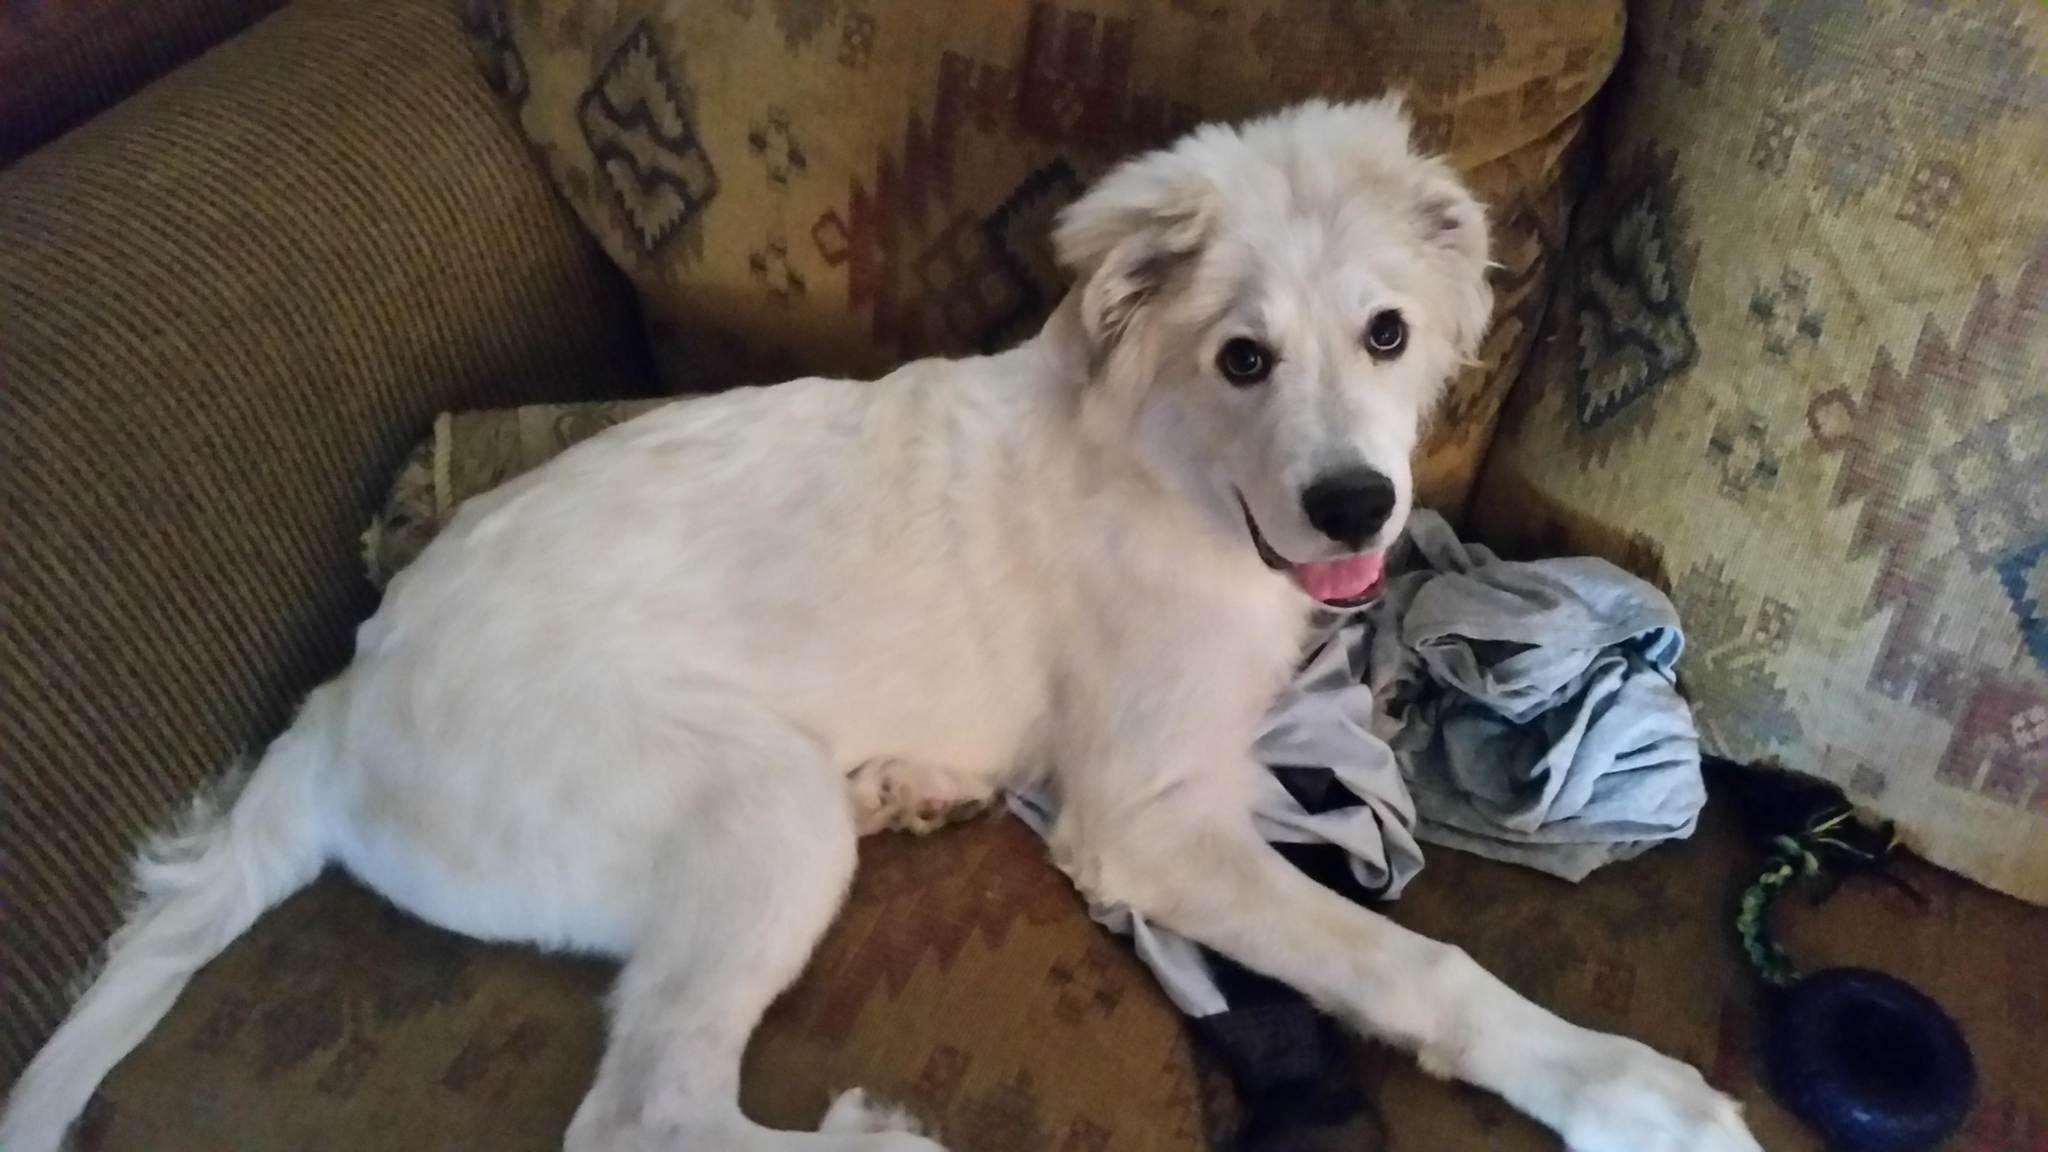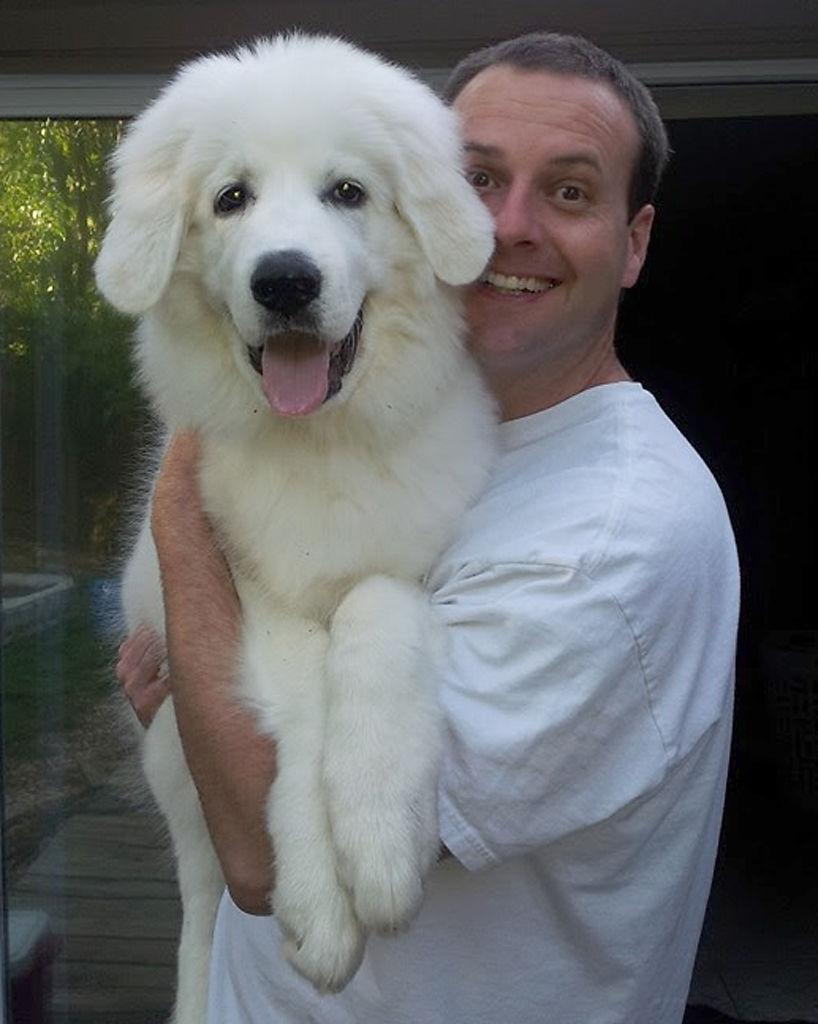The first image is the image on the left, the second image is the image on the right. Analyze the images presented: Is the assertion "In one of the images there is a person holding a large white dog." valid? Answer yes or no. Yes. The first image is the image on the left, the second image is the image on the right. Assess this claim about the two images: "An image shows a toddler next to a sitting white dog.". Correct or not? Answer yes or no. No. 